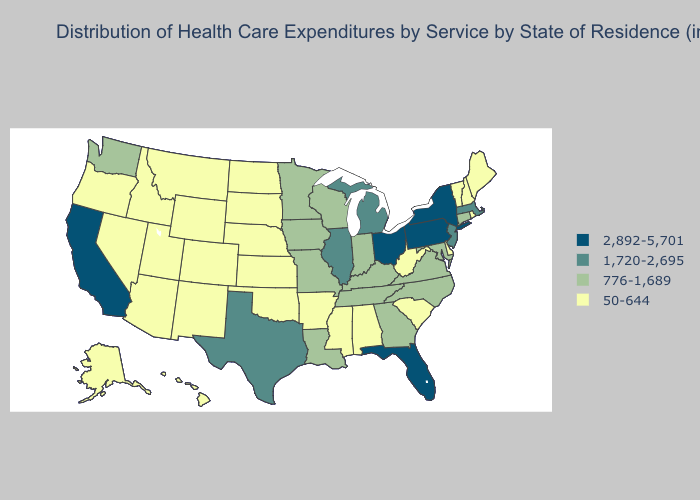What is the value of Alaska?
Keep it brief. 50-644. Does Idaho have the highest value in the West?
Concise answer only. No. What is the lowest value in states that border Texas?
Be succinct. 50-644. Does Florida have the highest value in the USA?
Answer briefly. Yes. Among the states that border Kansas , which have the lowest value?
Answer briefly. Colorado, Nebraska, Oklahoma. Does the map have missing data?
Answer briefly. No. What is the highest value in the USA?
Keep it brief. 2,892-5,701. Does Washington have the lowest value in the USA?
Quick response, please. No. Does North Dakota have the highest value in the MidWest?
Write a very short answer. No. Among the states that border Louisiana , which have the lowest value?
Concise answer only. Arkansas, Mississippi. What is the highest value in the MidWest ?
Be succinct. 2,892-5,701. Name the states that have a value in the range 2,892-5,701?
Write a very short answer. California, Florida, New York, Ohio, Pennsylvania. What is the lowest value in the USA?
Concise answer only. 50-644. What is the value of Nevada?
Be succinct. 50-644. What is the value of Utah?
Quick response, please. 50-644. 